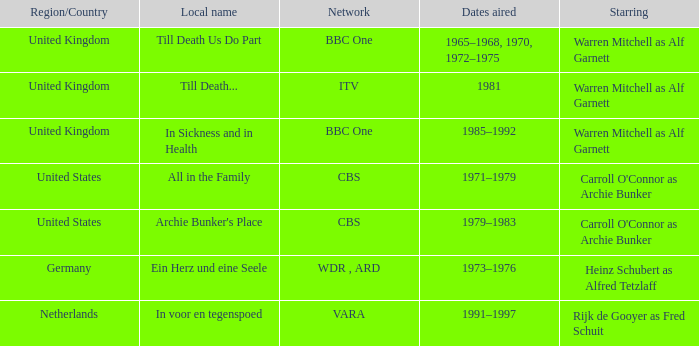What is the area-specific title for the episodes that were shown in 1981? Till Death... 